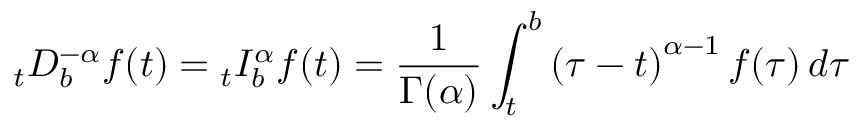Convert formula to latex. <formula><loc_0><loc_0><loc_500><loc_500>_ { t } D _ { b } ^ { - \alpha } f ( t ) _ { t } I _ { b } ^ { \alpha } f ( t ) = { \frac { 1 } { \Gamma ( \alpha ) } } \int _ { t } ^ { b } \left ( \tau - t \right ) ^ { \alpha - 1 } f ( \tau ) \, d \tau</formula> 